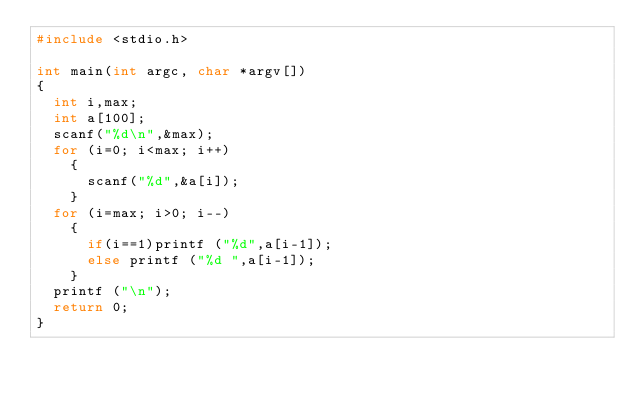<code> <loc_0><loc_0><loc_500><loc_500><_C_>#include <stdio.h>

int main(int argc, char *argv[])
{
  int i,max;
  int a[100];
  scanf("%d\n",&max);
  for (i=0; i<max; i++)
    {
      scanf("%d",&a[i]);
    }
  for (i=max; i>0; i--)
    {
      if(i==1)printf ("%d",a[i-1]);
      else printf ("%d ",a[i-1]);
    }
  printf ("\n");
  return 0;
}</code> 